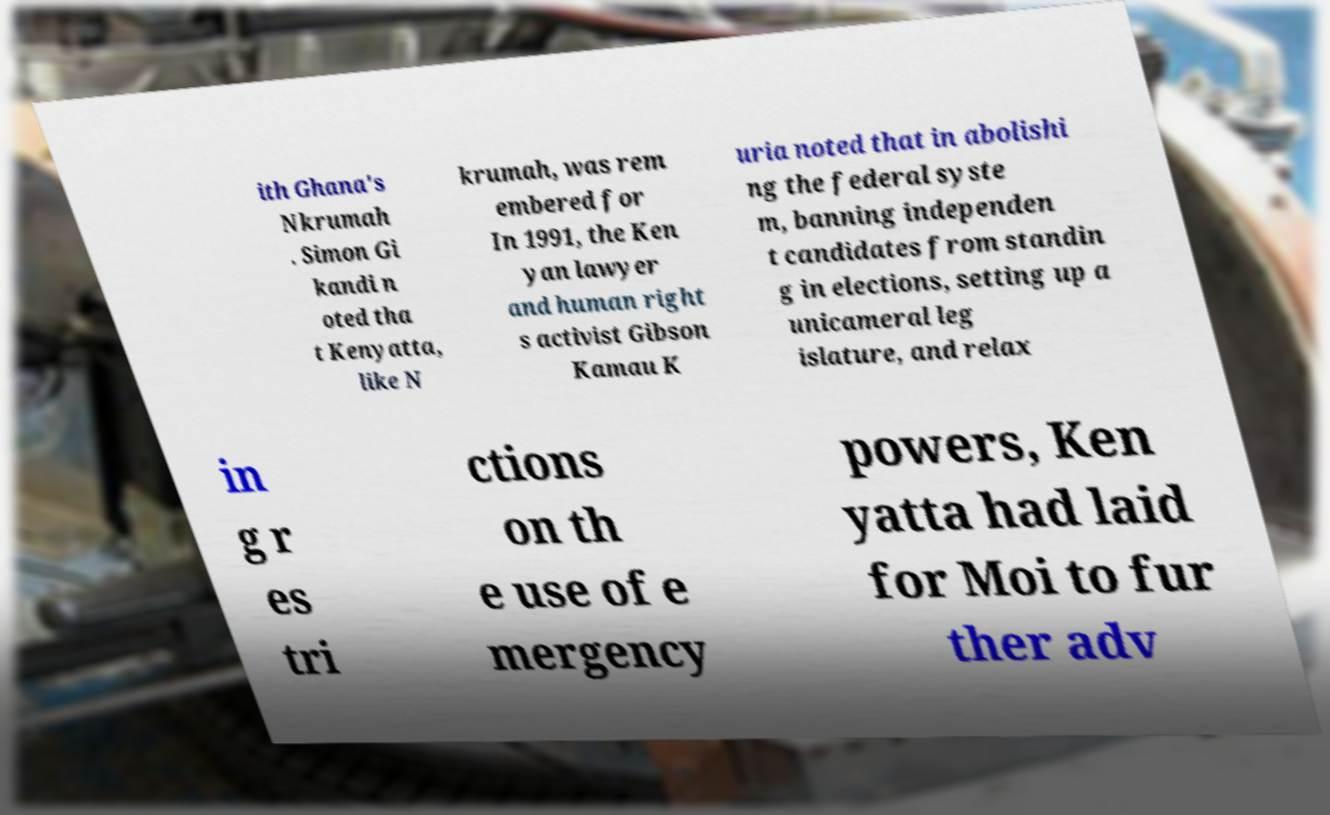Could you assist in decoding the text presented in this image and type it out clearly? ith Ghana's Nkrumah . Simon Gi kandi n oted tha t Kenyatta, like N krumah, was rem embered for In 1991, the Ken yan lawyer and human right s activist Gibson Kamau K uria noted that in abolishi ng the federal syste m, banning independen t candidates from standin g in elections, setting up a unicameral leg islature, and relax in g r es tri ctions on th e use of e mergency powers, Ken yatta had laid for Moi to fur ther adv 